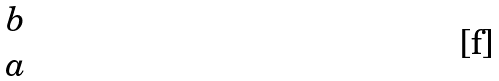<formula> <loc_0><loc_0><loc_500><loc_500>\begin{matrix} b \\ a \end{matrix}</formula> 